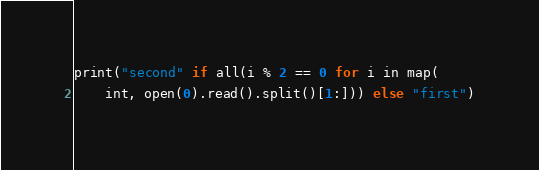<code> <loc_0><loc_0><loc_500><loc_500><_Python_>print("second" if all(i % 2 == 0 for i in map(
    int, open(0).read().split()[1:])) else "first")</code> 